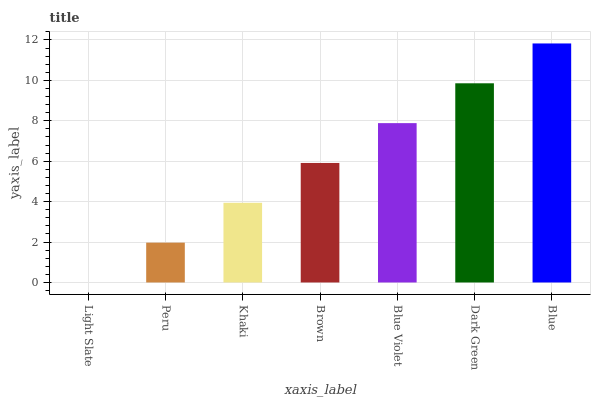Is Light Slate the minimum?
Answer yes or no. Yes. Is Blue the maximum?
Answer yes or no. Yes. Is Peru the minimum?
Answer yes or no. No. Is Peru the maximum?
Answer yes or no. No. Is Peru greater than Light Slate?
Answer yes or no. Yes. Is Light Slate less than Peru?
Answer yes or no. Yes. Is Light Slate greater than Peru?
Answer yes or no. No. Is Peru less than Light Slate?
Answer yes or no. No. Is Brown the high median?
Answer yes or no. Yes. Is Brown the low median?
Answer yes or no. Yes. Is Blue Violet the high median?
Answer yes or no. No. Is Light Slate the low median?
Answer yes or no. No. 